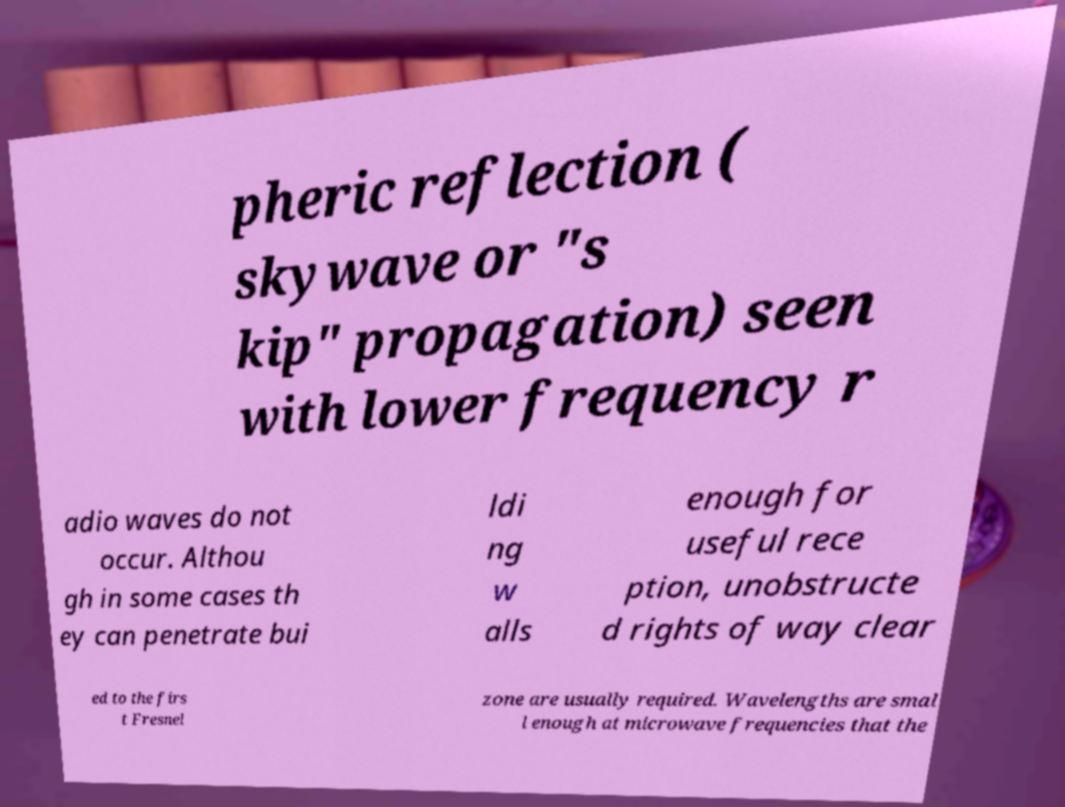Please identify and transcribe the text found in this image. pheric reflection ( skywave or "s kip" propagation) seen with lower frequency r adio waves do not occur. Althou gh in some cases th ey can penetrate bui ldi ng w alls enough for useful rece ption, unobstructe d rights of way clear ed to the firs t Fresnel zone are usually required. Wavelengths are smal l enough at microwave frequencies that the 